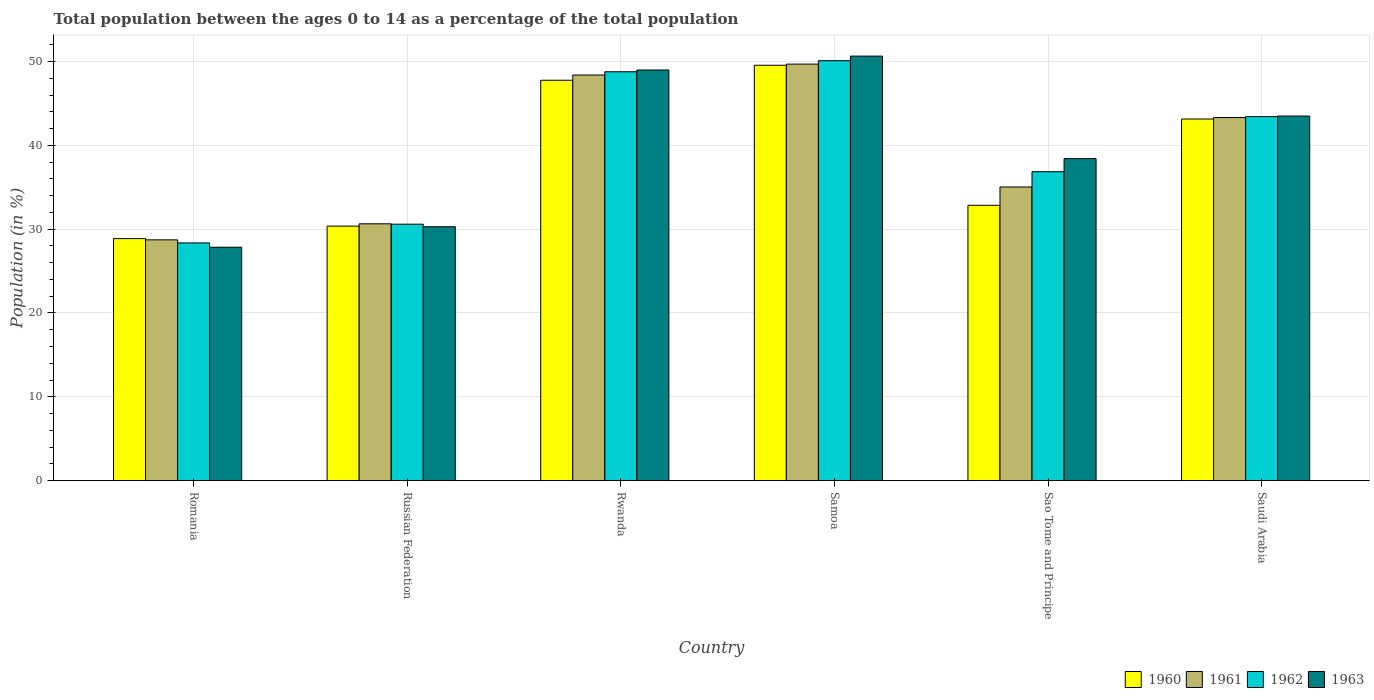How many different coloured bars are there?
Offer a terse response. 4. How many groups of bars are there?
Offer a very short reply. 6. How many bars are there on the 3rd tick from the right?
Ensure brevity in your answer.  4. What is the label of the 1st group of bars from the left?
Give a very brief answer. Romania. In how many cases, is the number of bars for a given country not equal to the number of legend labels?
Provide a short and direct response. 0. What is the percentage of the population ages 0 to 14 in 1962 in Samoa?
Keep it short and to the point. 50.11. Across all countries, what is the maximum percentage of the population ages 0 to 14 in 1961?
Ensure brevity in your answer.  49.7. Across all countries, what is the minimum percentage of the population ages 0 to 14 in 1960?
Provide a short and direct response. 28.88. In which country was the percentage of the population ages 0 to 14 in 1963 maximum?
Your response must be concise. Samoa. In which country was the percentage of the population ages 0 to 14 in 1963 minimum?
Offer a terse response. Romania. What is the total percentage of the population ages 0 to 14 in 1963 in the graph?
Your response must be concise. 239.71. What is the difference between the percentage of the population ages 0 to 14 in 1960 in Samoa and that in Sao Tome and Principe?
Offer a terse response. 16.71. What is the difference between the percentage of the population ages 0 to 14 in 1960 in Sao Tome and Principe and the percentage of the population ages 0 to 14 in 1962 in Samoa?
Keep it short and to the point. -17.26. What is the average percentage of the population ages 0 to 14 in 1962 per country?
Offer a very short reply. 39.69. What is the difference between the percentage of the population ages 0 to 14 of/in 1960 and percentage of the population ages 0 to 14 of/in 1962 in Sao Tome and Principe?
Ensure brevity in your answer.  -4.01. What is the ratio of the percentage of the population ages 0 to 14 in 1962 in Romania to that in Rwanda?
Offer a very short reply. 0.58. Is the difference between the percentage of the population ages 0 to 14 in 1960 in Rwanda and Samoa greater than the difference between the percentage of the population ages 0 to 14 in 1962 in Rwanda and Samoa?
Offer a very short reply. No. What is the difference between the highest and the second highest percentage of the population ages 0 to 14 in 1962?
Keep it short and to the point. -1.32. What is the difference between the highest and the lowest percentage of the population ages 0 to 14 in 1961?
Keep it short and to the point. 20.97. In how many countries, is the percentage of the population ages 0 to 14 in 1962 greater than the average percentage of the population ages 0 to 14 in 1962 taken over all countries?
Provide a succinct answer. 3. Is the sum of the percentage of the population ages 0 to 14 in 1963 in Romania and Rwanda greater than the maximum percentage of the population ages 0 to 14 in 1961 across all countries?
Offer a terse response. Yes. How many bars are there?
Offer a terse response. 24. How many countries are there in the graph?
Give a very brief answer. 6. What is the difference between two consecutive major ticks on the Y-axis?
Offer a very short reply. 10. Where does the legend appear in the graph?
Offer a terse response. Bottom right. How many legend labels are there?
Offer a very short reply. 4. What is the title of the graph?
Provide a short and direct response. Total population between the ages 0 to 14 as a percentage of the total population. Does "1977" appear as one of the legend labels in the graph?
Your response must be concise. No. What is the label or title of the X-axis?
Ensure brevity in your answer.  Country. What is the Population (in %) in 1960 in Romania?
Offer a terse response. 28.88. What is the Population (in %) of 1961 in Romania?
Your answer should be very brief. 28.73. What is the Population (in %) of 1962 in Romania?
Provide a succinct answer. 28.36. What is the Population (in %) of 1963 in Romania?
Your response must be concise. 27.85. What is the Population (in %) of 1960 in Russian Federation?
Your response must be concise. 30.37. What is the Population (in %) in 1961 in Russian Federation?
Offer a very short reply. 30.64. What is the Population (in %) of 1962 in Russian Federation?
Your answer should be compact. 30.6. What is the Population (in %) of 1963 in Russian Federation?
Offer a very short reply. 30.29. What is the Population (in %) in 1960 in Rwanda?
Your answer should be very brief. 47.77. What is the Population (in %) of 1961 in Rwanda?
Your answer should be very brief. 48.4. What is the Population (in %) of 1962 in Rwanda?
Give a very brief answer. 48.79. What is the Population (in %) of 1963 in Rwanda?
Offer a terse response. 49. What is the Population (in %) in 1960 in Samoa?
Your answer should be very brief. 49.56. What is the Population (in %) of 1961 in Samoa?
Offer a terse response. 49.7. What is the Population (in %) of 1962 in Samoa?
Provide a short and direct response. 50.11. What is the Population (in %) of 1963 in Samoa?
Ensure brevity in your answer.  50.65. What is the Population (in %) in 1960 in Sao Tome and Principe?
Your answer should be compact. 32.85. What is the Population (in %) in 1961 in Sao Tome and Principe?
Provide a short and direct response. 35.04. What is the Population (in %) of 1962 in Sao Tome and Principe?
Give a very brief answer. 36.86. What is the Population (in %) of 1963 in Sao Tome and Principe?
Offer a very short reply. 38.42. What is the Population (in %) of 1960 in Saudi Arabia?
Provide a succinct answer. 43.14. What is the Population (in %) in 1961 in Saudi Arabia?
Your answer should be very brief. 43.32. What is the Population (in %) in 1962 in Saudi Arabia?
Give a very brief answer. 43.43. What is the Population (in %) in 1963 in Saudi Arabia?
Offer a very short reply. 43.5. Across all countries, what is the maximum Population (in %) of 1960?
Make the answer very short. 49.56. Across all countries, what is the maximum Population (in %) of 1961?
Your answer should be compact. 49.7. Across all countries, what is the maximum Population (in %) in 1962?
Offer a terse response. 50.11. Across all countries, what is the maximum Population (in %) in 1963?
Ensure brevity in your answer.  50.65. Across all countries, what is the minimum Population (in %) in 1960?
Make the answer very short. 28.88. Across all countries, what is the minimum Population (in %) in 1961?
Give a very brief answer. 28.73. Across all countries, what is the minimum Population (in %) of 1962?
Your answer should be compact. 28.36. Across all countries, what is the minimum Population (in %) of 1963?
Offer a terse response. 27.85. What is the total Population (in %) of 1960 in the graph?
Make the answer very short. 232.57. What is the total Population (in %) of 1961 in the graph?
Your answer should be very brief. 235.83. What is the total Population (in %) of 1962 in the graph?
Ensure brevity in your answer.  238.14. What is the total Population (in %) in 1963 in the graph?
Keep it short and to the point. 239.71. What is the difference between the Population (in %) of 1960 in Romania and that in Russian Federation?
Offer a very short reply. -1.49. What is the difference between the Population (in %) of 1961 in Romania and that in Russian Federation?
Keep it short and to the point. -1.92. What is the difference between the Population (in %) in 1962 in Romania and that in Russian Federation?
Offer a terse response. -2.24. What is the difference between the Population (in %) in 1963 in Romania and that in Russian Federation?
Offer a terse response. -2.44. What is the difference between the Population (in %) of 1960 in Romania and that in Rwanda?
Provide a succinct answer. -18.9. What is the difference between the Population (in %) in 1961 in Romania and that in Rwanda?
Ensure brevity in your answer.  -19.67. What is the difference between the Population (in %) of 1962 in Romania and that in Rwanda?
Provide a short and direct response. -20.42. What is the difference between the Population (in %) in 1963 in Romania and that in Rwanda?
Give a very brief answer. -21.15. What is the difference between the Population (in %) of 1960 in Romania and that in Samoa?
Offer a very short reply. -20.69. What is the difference between the Population (in %) in 1961 in Romania and that in Samoa?
Ensure brevity in your answer.  -20.97. What is the difference between the Population (in %) in 1962 in Romania and that in Samoa?
Offer a very short reply. -21.74. What is the difference between the Population (in %) of 1963 in Romania and that in Samoa?
Offer a very short reply. -22.81. What is the difference between the Population (in %) in 1960 in Romania and that in Sao Tome and Principe?
Make the answer very short. -3.98. What is the difference between the Population (in %) in 1961 in Romania and that in Sao Tome and Principe?
Keep it short and to the point. -6.31. What is the difference between the Population (in %) of 1962 in Romania and that in Sao Tome and Principe?
Provide a succinct answer. -8.5. What is the difference between the Population (in %) of 1963 in Romania and that in Sao Tome and Principe?
Your answer should be compact. -10.57. What is the difference between the Population (in %) in 1960 in Romania and that in Saudi Arabia?
Offer a terse response. -14.27. What is the difference between the Population (in %) of 1961 in Romania and that in Saudi Arabia?
Ensure brevity in your answer.  -14.6. What is the difference between the Population (in %) of 1962 in Romania and that in Saudi Arabia?
Provide a succinct answer. -15.07. What is the difference between the Population (in %) in 1963 in Romania and that in Saudi Arabia?
Your response must be concise. -15.65. What is the difference between the Population (in %) of 1960 in Russian Federation and that in Rwanda?
Offer a terse response. -17.41. What is the difference between the Population (in %) of 1961 in Russian Federation and that in Rwanda?
Offer a terse response. -17.76. What is the difference between the Population (in %) of 1962 in Russian Federation and that in Rwanda?
Give a very brief answer. -18.19. What is the difference between the Population (in %) of 1963 in Russian Federation and that in Rwanda?
Your answer should be compact. -18.7. What is the difference between the Population (in %) of 1960 in Russian Federation and that in Samoa?
Give a very brief answer. -19.2. What is the difference between the Population (in %) in 1961 in Russian Federation and that in Samoa?
Your answer should be very brief. -19.06. What is the difference between the Population (in %) of 1962 in Russian Federation and that in Samoa?
Provide a short and direct response. -19.51. What is the difference between the Population (in %) of 1963 in Russian Federation and that in Samoa?
Offer a terse response. -20.36. What is the difference between the Population (in %) of 1960 in Russian Federation and that in Sao Tome and Principe?
Your response must be concise. -2.48. What is the difference between the Population (in %) of 1961 in Russian Federation and that in Sao Tome and Principe?
Offer a very short reply. -4.4. What is the difference between the Population (in %) in 1962 in Russian Federation and that in Sao Tome and Principe?
Your response must be concise. -6.26. What is the difference between the Population (in %) in 1963 in Russian Federation and that in Sao Tome and Principe?
Your answer should be very brief. -8.13. What is the difference between the Population (in %) of 1960 in Russian Federation and that in Saudi Arabia?
Your response must be concise. -12.78. What is the difference between the Population (in %) of 1961 in Russian Federation and that in Saudi Arabia?
Offer a very short reply. -12.68. What is the difference between the Population (in %) in 1962 in Russian Federation and that in Saudi Arabia?
Give a very brief answer. -12.83. What is the difference between the Population (in %) of 1963 in Russian Federation and that in Saudi Arabia?
Offer a very short reply. -13.21. What is the difference between the Population (in %) of 1960 in Rwanda and that in Samoa?
Ensure brevity in your answer.  -1.79. What is the difference between the Population (in %) of 1961 in Rwanda and that in Samoa?
Give a very brief answer. -1.3. What is the difference between the Population (in %) in 1962 in Rwanda and that in Samoa?
Offer a very short reply. -1.32. What is the difference between the Population (in %) of 1963 in Rwanda and that in Samoa?
Provide a succinct answer. -1.66. What is the difference between the Population (in %) in 1960 in Rwanda and that in Sao Tome and Principe?
Make the answer very short. 14.92. What is the difference between the Population (in %) of 1961 in Rwanda and that in Sao Tome and Principe?
Ensure brevity in your answer.  13.36. What is the difference between the Population (in %) of 1962 in Rwanda and that in Sao Tome and Principe?
Your answer should be compact. 11.93. What is the difference between the Population (in %) in 1963 in Rwanda and that in Sao Tome and Principe?
Make the answer very short. 10.58. What is the difference between the Population (in %) in 1960 in Rwanda and that in Saudi Arabia?
Offer a terse response. 4.63. What is the difference between the Population (in %) in 1961 in Rwanda and that in Saudi Arabia?
Your answer should be compact. 5.08. What is the difference between the Population (in %) of 1962 in Rwanda and that in Saudi Arabia?
Your answer should be very brief. 5.36. What is the difference between the Population (in %) of 1963 in Rwanda and that in Saudi Arabia?
Provide a succinct answer. 5.5. What is the difference between the Population (in %) of 1960 in Samoa and that in Sao Tome and Principe?
Keep it short and to the point. 16.71. What is the difference between the Population (in %) in 1961 in Samoa and that in Sao Tome and Principe?
Provide a short and direct response. 14.66. What is the difference between the Population (in %) of 1962 in Samoa and that in Sao Tome and Principe?
Give a very brief answer. 13.25. What is the difference between the Population (in %) in 1963 in Samoa and that in Sao Tome and Principe?
Give a very brief answer. 12.23. What is the difference between the Population (in %) of 1960 in Samoa and that in Saudi Arabia?
Your response must be concise. 6.42. What is the difference between the Population (in %) in 1961 in Samoa and that in Saudi Arabia?
Your answer should be compact. 6.38. What is the difference between the Population (in %) in 1962 in Samoa and that in Saudi Arabia?
Give a very brief answer. 6.68. What is the difference between the Population (in %) of 1963 in Samoa and that in Saudi Arabia?
Your response must be concise. 7.16. What is the difference between the Population (in %) of 1960 in Sao Tome and Principe and that in Saudi Arabia?
Ensure brevity in your answer.  -10.29. What is the difference between the Population (in %) of 1961 in Sao Tome and Principe and that in Saudi Arabia?
Ensure brevity in your answer.  -8.29. What is the difference between the Population (in %) in 1962 in Sao Tome and Principe and that in Saudi Arabia?
Offer a terse response. -6.57. What is the difference between the Population (in %) in 1963 in Sao Tome and Principe and that in Saudi Arabia?
Your response must be concise. -5.08. What is the difference between the Population (in %) of 1960 in Romania and the Population (in %) of 1961 in Russian Federation?
Give a very brief answer. -1.77. What is the difference between the Population (in %) of 1960 in Romania and the Population (in %) of 1962 in Russian Federation?
Provide a short and direct response. -1.72. What is the difference between the Population (in %) of 1960 in Romania and the Population (in %) of 1963 in Russian Federation?
Provide a short and direct response. -1.42. What is the difference between the Population (in %) of 1961 in Romania and the Population (in %) of 1962 in Russian Federation?
Provide a succinct answer. -1.87. What is the difference between the Population (in %) of 1961 in Romania and the Population (in %) of 1963 in Russian Federation?
Your response must be concise. -1.57. What is the difference between the Population (in %) of 1962 in Romania and the Population (in %) of 1963 in Russian Federation?
Your answer should be compact. -1.93. What is the difference between the Population (in %) of 1960 in Romania and the Population (in %) of 1961 in Rwanda?
Give a very brief answer. -19.52. What is the difference between the Population (in %) of 1960 in Romania and the Population (in %) of 1962 in Rwanda?
Provide a succinct answer. -19.91. What is the difference between the Population (in %) of 1960 in Romania and the Population (in %) of 1963 in Rwanda?
Ensure brevity in your answer.  -20.12. What is the difference between the Population (in %) of 1961 in Romania and the Population (in %) of 1962 in Rwanda?
Your response must be concise. -20.06. What is the difference between the Population (in %) in 1961 in Romania and the Population (in %) in 1963 in Rwanda?
Give a very brief answer. -20.27. What is the difference between the Population (in %) in 1962 in Romania and the Population (in %) in 1963 in Rwanda?
Ensure brevity in your answer.  -20.63. What is the difference between the Population (in %) of 1960 in Romania and the Population (in %) of 1961 in Samoa?
Your answer should be compact. -20.82. What is the difference between the Population (in %) of 1960 in Romania and the Population (in %) of 1962 in Samoa?
Ensure brevity in your answer.  -21.23. What is the difference between the Population (in %) in 1960 in Romania and the Population (in %) in 1963 in Samoa?
Offer a very short reply. -21.78. What is the difference between the Population (in %) of 1961 in Romania and the Population (in %) of 1962 in Samoa?
Your response must be concise. -21.38. What is the difference between the Population (in %) of 1961 in Romania and the Population (in %) of 1963 in Samoa?
Give a very brief answer. -21.93. What is the difference between the Population (in %) in 1962 in Romania and the Population (in %) in 1963 in Samoa?
Make the answer very short. -22.29. What is the difference between the Population (in %) of 1960 in Romania and the Population (in %) of 1961 in Sao Tome and Principe?
Ensure brevity in your answer.  -6.16. What is the difference between the Population (in %) in 1960 in Romania and the Population (in %) in 1962 in Sao Tome and Principe?
Your answer should be very brief. -7.98. What is the difference between the Population (in %) in 1960 in Romania and the Population (in %) in 1963 in Sao Tome and Principe?
Offer a terse response. -9.54. What is the difference between the Population (in %) in 1961 in Romania and the Population (in %) in 1962 in Sao Tome and Principe?
Offer a terse response. -8.13. What is the difference between the Population (in %) in 1961 in Romania and the Population (in %) in 1963 in Sao Tome and Principe?
Your answer should be very brief. -9.69. What is the difference between the Population (in %) in 1962 in Romania and the Population (in %) in 1963 in Sao Tome and Principe?
Provide a succinct answer. -10.06. What is the difference between the Population (in %) of 1960 in Romania and the Population (in %) of 1961 in Saudi Arabia?
Provide a short and direct response. -14.45. What is the difference between the Population (in %) of 1960 in Romania and the Population (in %) of 1962 in Saudi Arabia?
Provide a succinct answer. -14.55. What is the difference between the Population (in %) of 1960 in Romania and the Population (in %) of 1963 in Saudi Arabia?
Ensure brevity in your answer.  -14.62. What is the difference between the Population (in %) of 1961 in Romania and the Population (in %) of 1962 in Saudi Arabia?
Your answer should be compact. -14.7. What is the difference between the Population (in %) in 1961 in Romania and the Population (in %) in 1963 in Saudi Arabia?
Provide a short and direct response. -14.77. What is the difference between the Population (in %) of 1962 in Romania and the Population (in %) of 1963 in Saudi Arabia?
Offer a terse response. -15.14. What is the difference between the Population (in %) of 1960 in Russian Federation and the Population (in %) of 1961 in Rwanda?
Your answer should be compact. -18.03. What is the difference between the Population (in %) of 1960 in Russian Federation and the Population (in %) of 1962 in Rwanda?
Offer a very short reply. -18.42. What is the difference between the Population (in %) of 1960 in Russian Federation and the Population (in %) of 1963 in Rwanda?
Offer a very short reply. -18.63. What is the difference between the Population (in %) in 1961 in Russian Federation and the Population (in %) in 1962 in Rwanda?
Your response must be concise. -18.14. What is the difference between the Population (in %) in 1961 in Russian Federation and the Population (in %) in 1963 in Rwanda?
Give a very brief answer. -18.35. What is the difference between the Population (in %) of 1962 in Russian Federation and the Population (in %) of 1963 in Rwanda?
Provide a succinct answer. -18.4. What is the difference between the Population (in %) of 1960 in Russian Federation and the Population (in %) of 1961 in Samoa?
Offer a very short reply. -19.33. What is the difference between the Population (in %) of 1960 in Russian Federation and the Population (in %) of 1962 in Samoa?
Ensure brevity in your answer.  -19.74. What is the difference between the Population (in %) of 1960 in Russian Federation and the Population (in %) of 1963 in Samoa?
Provide a succinct answer. -20.29. What is the difference between the Population (in %) in 1961 in Russian Federation and the Population (in %) in 1962 in Samoa?
Ensure brevity in your answer.  -19.46. What is the difference between the Population (in %) of 1961 in Russian Federation and the Population (in %) of 1963 in Samoa?
Your answer should be very brief. -20.01. What is the difference between the Population (in %) in 1962 in Russian Federation and the Population (in %) in 1963 in Samoa?
Ensure brevity in your answer.  -20.06. What is the difference between the Population (in %) in 1960 in Russian Federation and the Population (in %) in 1961 in Sao Tome and Principe?
Offer a very short reply. -4.67. What is the difference between the Population (in %) of 1960 in Russian Federation and the Population (in %) of 1962 in Sao Tome and Principe?
Ensure brevity in your answer.  -6.49. What is the difference between the Population (in %) of 1960 in Russian Federation and the Population (in %) of 1963 in Sao Tome and Principe?
Provide a short and direct response. -8.05. What is the difference between the Population (in %) of 1961 in Russian Federation and the Population (in %) of 1962 in Sao Tome and Principe?
Your answer should be very brief. -6.22. What is the difference between the Population (in %) in 1961 in Russian Federation and the Population (in %) in 1963 in Sao Tome and Principe?
Keep it short and to the point. -7.78. What is the difference between the Population (in %) of 1962 in Russian Federation and the Population (in %) of 1963 in Sao Tome and Principe?
Offer a terse response. -7.82. What is the difference between the Population (in %) of 1960 in Russian Federation and the Population (in %) of 1961 in Saudi Arabia?
Give a very brief answer. -12.96. What is the difference between the Population (in %) in 1960 in Russian Federation and the Population (in %) in 1962 in Saudi Arabia?
Offer a terse response. -13.06. What is the difference between the Population (in %) in 1960 in Russian Federation and the Population (in %) in 1963 in Saudi Arabia?
Give a very brief answer. -13.13. What is the difference between the Population (in %) of 1961 in Russian Federation and the Population (in %) of 1962 in Saudi Arabia?
Your response must be concise. -12.79. What is the difference between the Population (in %) of 1961 in Russian Federation and the Population (in %) of 1963 in Saudi Arabia?
Make the answer very short. -12.86. What is the difference between the Population (in %) of 1962 in Russian Federation and the Population (in %) of 1963 in Saudi Arabia?
Your answer should be very brief. -12.9. What is the difference between the Population (in %) of 1960 in Rwanda and the Population (in %) of 1961 in Samoa?
Offer a terse response. -1.93. What is the difference between the Population (in %) of 1960 in Rwanda and the Population (in %) of 1962 in Samoa?
Your response must be concise. -2.33. What is the difference between the Population (in %) in 1960 in Rwanda and the Population (in %) in 1963 in Samoa?
Offer a terse response. -2.88. What is the difference between the Population (in %) in 1961 in Rwanda and the Population (in %) in 1962 in Samoa?
Your response must be concise. -1.71. What is the difference between the Population (in %) in 1961 in Rwanda and the Population (in %) in 1963 in Samoa?
Your answer should be very brief. -2.25. What is the difference between the Population (in %) in 1962 in Rwanda and the Population (in %) in 1963 in Samoa?
Provide a short and direct response. -1.87. What is the difference between the Population (in %) of 1960 in Rwanda and the Population (in %) of 1961 in Sao Tome and Principe?
Your answer should be very brief. 12.74. What is the difference between the Population (in %) of 1960 in Rwanda and the Population (in %) of 1962 in Sao Tome and Principe?
Give a very brief answer. 10.91. What is the difference between the Population (in %) of 1960 in Rwanda and the Population (in %) of 1963 in Sao Tome and Principe?
Provide a short and direct response. 9.35. What is the difference between the Population (in %) of 1961 in Rwanda and the Population (in %) of 1962 in Sao Tome and Principe?
Offer a terse response. 11.54. What is the difference between the Population (in %) of 1961 in Rwanda and the Population (in %) of 1963 in Sao Tome and Principe?
Your response must be concise. 9.98. What is the difference between the Population (in %) of 1962 in Rwanda and the Population (in %) of 1963 in Sao Tome and Principe?
Ensure brevity in your answer.  10.37. What is the difference between the Population (in %) in 1960 in Rwanda and the Population (in %) in 1961 in Saudi Arabia?
Your answer should be compact. 4.45. What is the difference between the Population (in %) of 1960 in Rwanda and the Population (in %) of 1962 in Saudi Arabia?
Ensure brevity in your answer.  4.34. What is the difference between the Population (in %) of 1960 in Rwanda and the Population (in %) of 1963 in Saudi Arabia?
Offer a very short reply. 4.28. What is the difference between the Population (in %) in 1961 in Rwanda and the Population (in %) in 1962 in Saudi Arabia?
Ensure brevity in your answer.  4.97. What is the difference between the Population (in %) in 1961 in Rwanda and the Population (in %) in 1963 in Saudi Arabia?
Offer a terse response. 4.9. What is the difference between the Population (in %) of 1962 in Rwanda and the Population (in %) of 1963 in Saudi Arabia?
Make the answer very short. 5.29. What is the difference between the Population (in %) of 1960 in Samoa and the Population (in %) of 1961 in Sao Tome and Principe?
Offer a very short reply. 14.52. What is the difference between the Population (in %) in 1960 in Samoa and the Population (in %) in 1962 in Sao Tome and Principe?
Your response must be concise. 12.7. What is the difference between the Population (in %) in 1960 in Samoa and the Population (in %) in 1963 in Sao Tome and Principe?
Offer a terse response. 11.14. What is the difference between the Population (in %) of 1961 in Samoa and the Population (in %) of 1962 in Sao Tome and Principe?
Offer a terse response. 12.84. What is the difference between the Population (in %) in 1961 in Samoa and the Population (in %) in 1963 in Sao Tome and Principe?
Offer a very short reply. 11.28. What is the difference between the Population (in %) of 1962 in Samoa and the Population (in %) of 1963 in Sao Tome and Principe?
Your response must be concise. 11.69. What is the difference between the Population (in %) in 1960 in Samoa and the Population (in %) in 1961 in Saudi Arabia?
Your response must be concise. 6.24. What is the difference between the Population (in %) in 1960 in Samoa and the Population (in %) in 1962 in Saudi Arabia?
Offer a very short reply. 6.13. What is the difference between the Population (in %) of 1960 in Samoa and the Population (in %) of 1963 in Saudi Arabia?
Provide a short and direct response. 6.06. What is the difference between the Population (in %) in 1961 in Samoa and the Population (in %) in 1962 in Saudi Arabia?
Keep it short and to the point. 6.27. What is the difference between the Population (in %) in 1961 in Samoa and the Population (in %) in 1963 in Saudi Arabia?
Offer a very short reply. 6.2. What is the difference between the Population (in %) of 1962 in Samoa and the Population (in %) of 1963 in Saudi Arabia?
Give a very brief answer. 6.61. What is the difference between the Population (in %) of 1960 in Sao Tome and Principe and the Population (in %) of 1961 in Saudi Arabia?
Your answer should be compact. -10.47. What is the difference between the Population (in %) of 1960 in Sao Tome and Principe and the Population (in %) of 1962 in Saudi Arabia?
Your response must be concise. -10.58. What is the difference between the Population (in %) of 1960 in Sao Tome and Principe and the Population (in %) of 1963 in Saudi Arabia?
Provide a short and direct response. -10.65. What is the difference between the Population (in %) of 1961 in Sao Tome and Principe and the Population (in %) of 1962 in Saudi Arabia?
Provide a succinct answer. -8.39. What is the difference between the Population (in %) in 1961 in Sao Tome and Principe and the Population (in %) in 1963 in Saudi Arabia?
Keep it short and to the point. -8.46. What is the difference between the Population (in %) of 1962 in Sao Tome and Principe and the Population (in %) of 1963 in Saudi Arabia?
Your response must be concise. -6.64. What is the average Population (in %) in 1960 per country?
Keep it short and to the point. 38.76. What is the average Population (in %) of 1961 per country?
Give a very brief answer. 39.3. What is the average Population (in %) in 1962 per country?
Keep it short and to the point. 39.69. What is the average Population (in %) of 1963 per country?
Give a very brief answer. 39.95. What is the difference between the Population (in %) in 1960 and Population (in %) in 1961 in Romania?
Give a very brief answer. 0.15. What is the difference between the Population (in %) of 1960 and Population (in %) of 1962 in Romania?
Offer a terse response. 0.51. What is the difference between the Population (in %) in 1960 and Population (in %) in 1963 in Romania?
Offer a very short reply. 1.03. What is the difference between the Population (in %) of 1961 and Population (in %) of 1962 in Romania?
Offer a terse response. 0.36. What is the difference between the Population (in %) in 1961 and Population (in %) in 1963 in Romania?
Your response must be concise. 0.88. What is the difference between the Population (in %) in 1962 and Population (in %) in 1963 in Romania?
Your answer should be compact. 0.51. What is the difference between the Population (in %) in 1960 and Population (in %) in 1961 in Russian Federation?
Your answer should be compact. -0.28. What is the difference between the Population (in %) of 1960 and Population (in %) of 1962 in Russian Federation?
Offer a very short reply. -0.23. What is the difference between the Population (in %) in 1960 and Population (in %) in 1963 in Russian Federation?
Offer a very short reply. 0.07. What is the difference between the Population (in %) in 1961 and Population (in %) in 1962 in Russian Federation?
Your answer should be very brief. 0.04. What is the difference between the Population (in %) of 1961 and Population (in %) of 1963 in Russian Federation?
Provide a short and direct response. 0.35. What is the difference between the Population (in %) in 1962 and Population (in %) in 1963 in Russian Federation?
Offer a terse response. 0.3. What is the difference between the Population (in %) of 1960 and Population (in %) of 1961 in Rwanda?
Offer a terse response. -0.63. What is the difference between the Population (in %) of 1960 and Population (in %) of 1962 in Rwanda?
Make the answer very short. -1.01. What is the difference between the Population (in %) in 1960 and Population (in %) in 1963 in Rwanda?
Your response must be concise. -1.22. What is the difference between the Population (in %) in 1961 and Population (in %) in 1962 in Rwanda?
Give a very brief answer. -0.39. What is the difference between the Population (in %) in 1961 and Population (in %) in 1963 in Rwanda?
Offer a very short reply. -0.6. What is the difference between the Population (in %) of 1962 and Population (in %) of 1963 in Rwanda?
Keep it short and to the point. -0.21. What is the difference between the Population (in %) of 1960 and Population (in %) of 1961 in Samoa?
Offer a very short reply. -0.14. What is the difference between the Population (in %) of 1960 and Population (in %) of 1962 in Samoa?
Provide a short and direct response. -0.54. What is the difference between the Population (in %) of 1960 and Population (in %) of 1963 in Samoa?
Your response must be concise. -1.09. What is the difference between the Population (in %) in 1961 and Population (in %) in 1962 in Samoa?
Your response must be concise. -0.41. What is the difference between the Population (in %) in 1961 and Population (in %) in 1963 in Samoa?
Provide a succinct answer. -0.95. What is the difference between the Population (in %) of 1962 and Population (in %) of 1963 in Samoa?
Make the answer very short. -0.55. What is the difference between the Population (in %) of 1960 and Population (in %) of 1961 in Sao Tome and Principe?
Offer a very short reply. -2.19. What is the difference between the Population (in %) in 1960 and Population (in %) in 1962 in Sao Tome and Principe?
Offer a very short reply. -4.01. What is the difference between the Population (in %) in 1960 and Population (in %) in 1963 in Sao Tome and Principe?
Provide a succinct answer. -5.57. What is the difference between the Population (in %) of 1961 and Population (in %) of 1962 in Sao Tome and Principe?
Your response must be concise. -1.82. What is the difference between the Population (in %) of 1961 and Population (in %) of 1963 in Sao Tome and Principe?
Provide a short and direct response. -3.38. What is the difference between the Population (in %) in 1962 and Population (in %) in 1963 in Sao Tome and Principe?
Provide a short and direct response. -1.56. What is the difference between the Population (in %) of 1960 and Population (in %) of 1961 in Saudi Arabia?
Give a very brief answer. -0.18. What is the difference between the Population (in %) in 1960 and Population (in %) in 1962 in Saudi Arabia?
Offer a terse response. -0.28. What is the difference between the Population (in %) of 1960 and Population (in %) of 1963 in Saudi Arabia?
Your answer should be compact. -0.35. What is the difference between the Population (in %) of 1961 and Population (in %) of 1962 in Saudi Arabia?
Your answer should be very brief. -0.11. What is the difference between the Population (in %) of 1961 and Population (in %) of 1963 in Saudi Arabia?
Your response must be concise. -0.17. What is the difference between the Population (in %) of 1962 and Population (in %) of 1963 in Saudi Arabia?
Provide a short and direct response. -0.07. What is the ratio of the Population (in %) in 1960 in Romania to that in Russian Federation?
Offer a very short reply. 0.95. What is the ratio of the Population (in %) in 1961 in Romania to that in Russian Federation?
Make the answer very short. 0.94. What is the ratio of the Population (in %) in 1962 in Romania to that in Russian Federation?
Give a very brief answer. 0.93. What is the ratio of the Population (in %) of 1963 in Romania to that in Russian Federation?
Provide a short and direct response. 0.92. What is the ratio of the Population (in %) in 1960 in Romania to that in Rwanda?
Provide a short and direct response. 0.6. What is the ratio of the Population (in %) of 1961 in Romania to that in Rwanda?
Your response must be concise. 0.59. What is the ratio of the Population (in %) in 1962 in Romania to that in Rwanda?
Ensure brevity in your answer.  0.58. What is the ratio of the Population (in %) of 1963 in Romania to that in Rwanda?
Your answer should be compact. 0.57. What is the ratio of the Population (in %) in 1960 in Romania to that in Samoa?
Your answer should be compact. 0.58. What is the ratio of the Population (in %) in 1961 in Romania to that in Samoa?
Your answer should be compact. 0.58. What is the ratio of the Population (in %) in 1962 in Romania to that in Samoa?
Your answer should be compact. 0.57. What is the ratio of the Population (in %) of 1963 in Romania to that in Samoa?
Offer a terse response. 0.55. What is the ratio of the Population (in %) of 1960 in Romania to that in Sao Tome and Principe?
Your answer should be very brief. 0.88. What is the ratio of the Population (in %) in 1961 in Romania to that in Sao Tome and Principe?
Your response must be concise. 0.82. What is the ratio of the Population (in %) in 1962 in Romania to that in Sao Tome and Principe?
Your answer should be compact. 0.77. What is the ratio of the Population (in %) of 1963 in Romania to that in Sao Tome and Principe?
Your answer should be compact. 0.72. What is the ratio of the Population (in %) of 1960 in Romania to that in Saudi Arabia?
Provide a short and direct response. 0.67. What is the ratio of the Population (in %) in 1961 in Romania to that in Saudi Arabia?
Ensure brevity in your answer.  0.66. What is the ratio of the Population (in %) of 1962 in Romania to that in Saudi Arabia?
Offer a terse response. 0.65. What is the ratio of the Population (in %) in 1963 in Romania to that in Saudi Arabia?
Offer a terse response. 0.64. What is the ratio of the Population (in %) in 1960 in Russian Federation to that in Rwanda?
Your response must be concise. 0.64. What is the ratio of the Population (in %) in 1961 in Russian Federation to that in Rwanda?
Keep it short and to the point. 0.63. What is the ratio of the Population (in %) of 1962 in Russian Federation to that in Rwanda?
Ensure brevity in your answer.  0.63. What is the ratio of the Population (in %) of 1963 in Russian Federation to that in Rwanda?
Your answer should be compact. 0.62. What is the ratio of the Population (in %) in 1960 in Russian Federation to that in Samoa?
Give a very brief answer. 0.61. What is the ratio of the Population (in %) in 1961 in Russian Federation to that in Samoa?
Your response must be concise. 0.62. What is the ratio of the Population (in %) in 1962 in Russian Federation to that in Samoa?
Provide a short and direct response. 0.61. What is the ratio of the Population (in %) in 1963 in Russian Federation to that in Samoa?
Your answer should be compact. 0.6. What is the ratio of the Population (in %) of 1960 in Russian Federation to that in Sao Tome and Principe?
Provide a succinct answer. 0.92. What is the ratio of the Population (in %) in 1961 in Russian Federation to that in Sao Tome and Principe?
Provide a short and direct response. 0.87. What is the ratio of the Population (in %) in 1962 in Russian Federation to that in Sao Tome and Principe?
Your answer should be compact. 0.83. What is the ratio of the Population (in %) of 1963 in Russian Federation to that in Sao Tome and Principe?
Provide a short and direct response. 0.79. What is the ratio of the Population (in %) of 1960 in Russian Federation to that in Saudi Arabia?
Provide a short and direct response. 0.7. What is the ratio of the Population (in %) in 1961 in Russian Federation to that in Saudi Arabia?
Your answer should be very brief. 0.71. What is the ratio of the Population (in %) in 1962 in Russian Federation to that in Saudi Arabia?
Keep it short and to the point. 0.7. What is the ratio of the Population (in %) in 1963 in Russian Federation to that in Saudi Arabia?
Ensure brevity in your answer.  0.7. What is the ratio of the Population (in %) of 1960 in Rwanda to that in Samoa?
Your answer should be compact. 0.96. What is the ratio of the Population (in %) in 1961 in Rwanda to that in Samoa?
Make the answer very short. 0.97. What is the ratio of the Population (in %) in 1962 in Rwanda to that in Samoa?
Your answer should be very brief. 0.97. What is the ratio of the Population (in %) of 1963 in Rwanda to that in Samoa?
Your answer should be compact. 0.97. What is the ratio of the Population (in %) in 1960 in Rwanda to that in Sao Tome and Principe?
Keep it short and to the point. 1.45. What is the ratio of the Population (in %) in 1961 in Rwanda to that in Sao Tome and Principe?
Make the answer very short. 1.38. What is the ratio of the Population (in %) in 1962 in Rwanda to that in Sao Tome and Principe?
Offer a terse response. 1.32. What is the ratio of the Population (in %) in 1963 in Rwanda to that in Sao Tome and Principe?
Give a very brief answer. 1.28. What is the ratio of the Population (in %) of 1960 in Rwanda to that in Saudi Arabia?
Your response must be concise. 1.11. What is the ratio of the Population (in %) in 1961 in Rwanda to that in Saudi Arabia?
Your answer should be compact. 1.12. What is the ratio of the Population (in %) of 1962 in Rwanda to that in Saudi Arabia?
Provide a short and direct response. 1.12. What is the ratio of the Population (in %) of 1963 in Rwanda to that in Saudi Arabia?
Provide a short and direct response. 1.13. What is the ratio of the Population (in %) of 1960 in Samoa to that in Sao Tome and Principe?
Your response must be concise. 1.51. What is the ratio of the Population (in %) of 1961 in Samoa to that in Sao Tome and Principe?
Make the answer very short. 1.42. What is the ratio of the Population (in %) in 1962 in Samoa to that in Sao Tome and Principe?
Your answer should be very brief. 1.36. What is the ratio of the Population (in %) in 1963 in Samoa to that in Sao Tome and Principe?
Your answer should be very brief. 1.32. What is the ratio of the Population (in %) of 1960 in Samoa to that in Saudi Arabia?
Give a very brief answer. 1.15. What is the ratio of the Population (in %) of 1961 in Samoa to that in Saudi Arabia?
Offer a very short reply. 1.15. What is the ratio of the Population (in %) in 1962 in Samoa to that in Saudi Arabia?
Give a very brief answer. 1.15. What is the ratio of the Population (in %) of 1963 in Samoa to that in Saudi Arabia?
Offer a very short reply. 1.16. What is the ratio of the Population (in %) in 1960 in Sao Tome and Principe to that in Saudi Arabia?
Provide a short and direct response. 0.76. What is the ratio of the Population (in %) in 1961 in Sao Tome and Principe to that in Saudi Arabia?
Provide a short and direct response. 0.81. What is the ratio of the Population (in %) of 1962 in Sao Tome and Principe to that in Saudi Arabia?
Give a very brief answer. 0.85. What is the ratio of the Population (in %) of 1963 in Sao Tome and Principe to that in Saudi Arabia?
Make the answer very short. 0.88. What is the difference between the highest and the second highest Population (in %) in 1960?
Your response must be concise. 1.79. What is the difference between the highest and the second highest Population (in %) of 1961?
Provide a succinct answer. 1.3. What is the difference between the highest and the second highest Population (in %) of 1962?
Your response must be concise. 1.32. What is the difference between the highest and the second highest Population (in %) of 1963?
Give a very brief answer. 1.66. What is the difference between the highest and the lowest Population (in %) in 1960?
Offer a very short reply. 20.69. What is the difference between the highest and the lowest Population (in %) in 1961?
Offer a terse response. 20.97. What is the difference between the highest and the lowest Population (in %) in 1962?
Provide a succinct answer. 21.74. What is the difference between the highest and the lowest Population (in %) in 1963?
Offer a very short reply. 22.81. 